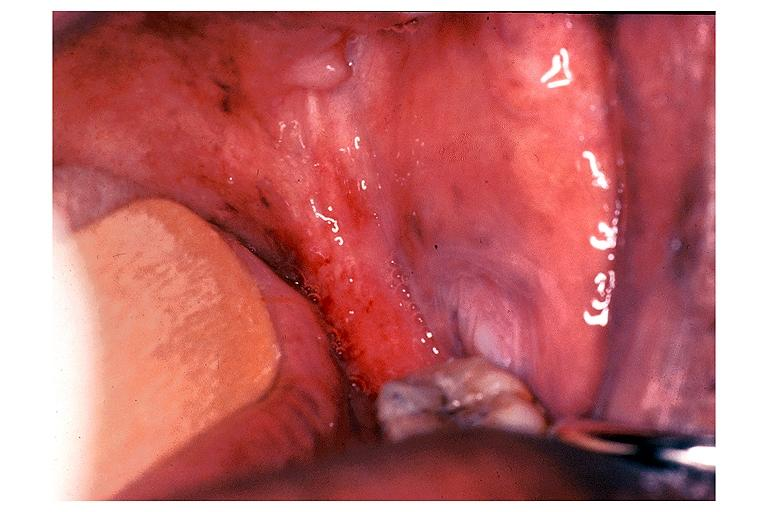s oral present?
Answer the question using a single word or phrase. Yes 